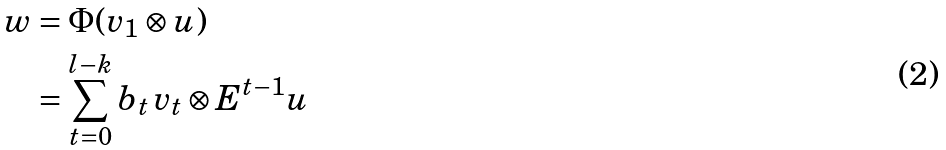Convert formula to latex. <formula><loc_0><loc_0><loc_500><loc_500>w & = \Phi ( v _ { 1 } \otimes u ) \\ & = \sum _ { t = 0 } ^ { l - k } b _ { t } \, v _ { t } \otimes E ^ { t - 1 } u</formula> 